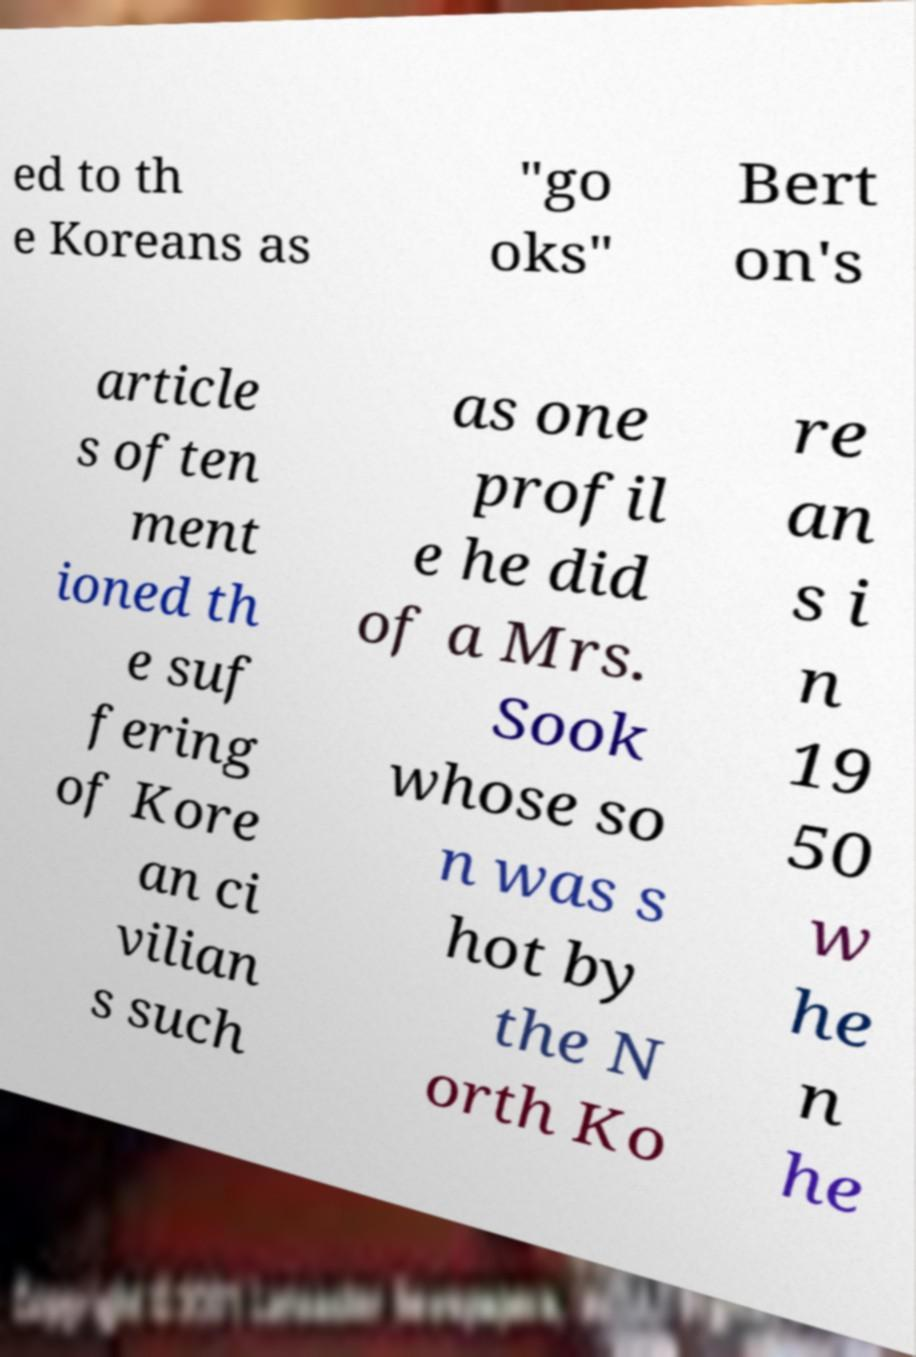Please identify and transcribe the text found in this image. ed to th e Koreans as "go oks" Bert on's article s often ment ioned th e suf fering of Kore an ci vilian s such as one profil e he did of a Mrs. Sook whose so n was s hot by the N orth Ko re an s i n 19 50 w he n he 